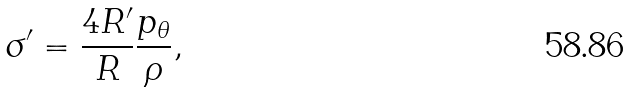Convert formula to latex. <formula><loc_0><loc_0><loc_500><loc_500>\sigma ^ { \prime } = \frac { 4 R ^ { \prime } } R \frac { p _ { \theta } } \rho ,</formula> 